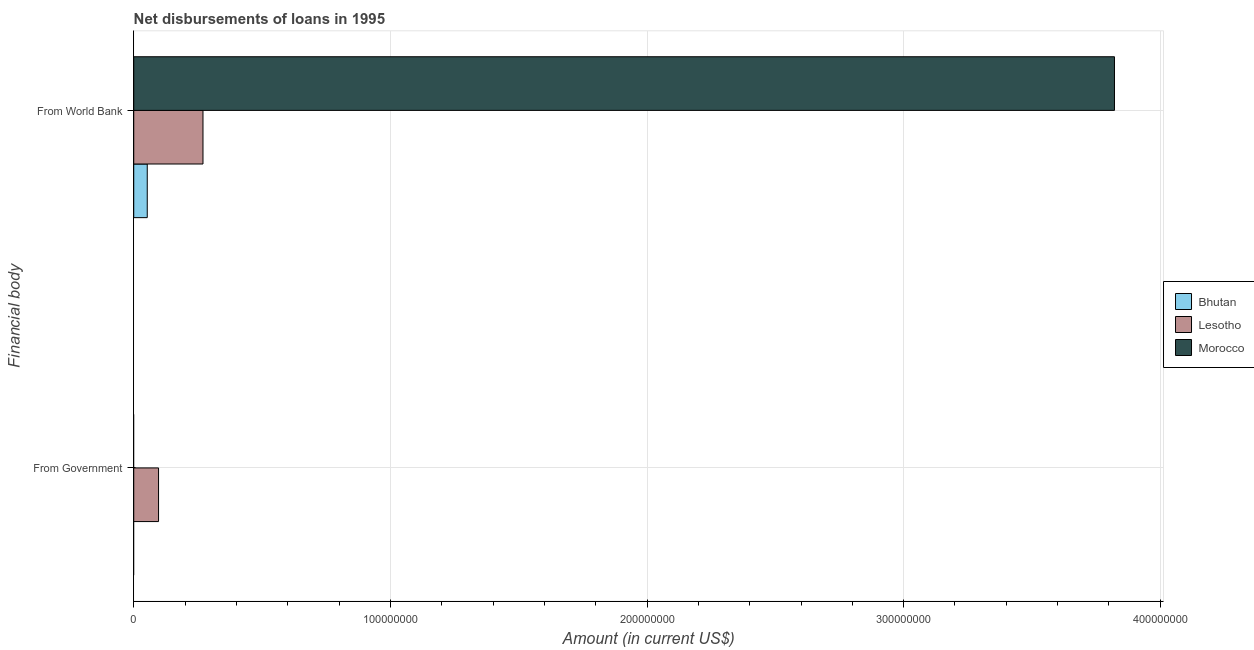How many different coloured bars are there?
Your answer should be compact. 3. How many bars are there on the 1st tick from the top?
Provide a succinct answer. 3. What is the label of the 1st group of bars from the top?
Your answer should be compact. From World Bank. What is the net disbursements of loan from government in Morocco?
Offer a very short reply. 0. Across all countries, what is the maximum net disbursements of loan from world bank?
Your answer should be very brief. 3.82e+08. Across all countries, what is the minimum net disbursements of loan from government?
Give a very brief answer. 0. In which country was the net disbursements of loan from government maximum?
Your response must be concise. Lesotho. What is the total net disbursements of loan from world bank in the graph?
Your response must be concise. 4.14e+08. What is the difference between the net disbursements of loan from world bank in Morocco and that in Lesotho?
Give a very brief answer. 3.55e+08. What is the difference between the net disbursements of loan from world bank in Lesotho and the net disbursements of loan from government in Bhutan?
Your answer should be compact. 2.70e+07. What is the average net disbursements of loan from world bank per country?
Provide a succinct answer. 1.38e+08. What is the difference between the net disbursements of loan from world bank and net disbursements of loan from government in Lesotho?
Keep it short and to the point. 1.73e+07. In how many countries, is the net disbursements of loan from government greater than 20000000 US$?
Your answer should be compact. 0. What is the ratio of the net disbursements of loan from world bank in Morocco to that in Lesotho?
Keep it short and to the point. 14.16. How many bars are there?
Your answer should be very brief. 4. Are all the bars in the graph horizontal?
Your answer should be very brief. Yes. What is the difference between two consecutive major ticks on the X-axis?
Keep it short and to the point. 1.00e+08. Are the values on the major ticks of X-axis written in scientific E-notation?
Offer a terse response. No. Does the graph contain grids?
Offer a terse response. Yes. Where does the legend appear in the graph?
Keep it short and to the point. Center right. What is the title of the graph?
Ensure brevity in your answer.  Net disbursements of loans in 1995. Does "South Sudan" appear as one of the legend labels in the graph?
Your answer should be compact. No. What is the label or title of the Y-axis?
Make the answer very short. Financial body. What is the Amount (in current US$) in Lesotho in From Government?
Your answer should be very brief. 9.67e+06. What is the Amount (in current US$) of Bhutan in From World Bank?
Your answer should be very brief. 5.26e+06. What is the Amount (in current US$) in Lesotho in From World Bank?
Offer a terse response. 2.70e+07. What is the Amount (in current US$) of Morocco in From World Bank?
Your response must be concise. 3.82e+08. Across all Financial body, what is the maximum Amount (in current US$) of Bhutan?
Provide a succinct answer. 5.26e+06. Across all Financial body, what is the maximum Amount (in current US$) in Lesotho?
Make the answer very short. 2.70e+07. Across all Financial body, what is the maximum Amount (in current US$) of Morocco?
Provide a short and direct response. 3.82e+08. Across all Financial body, what is the minimum Amount (in current US$) of Lesotho?
Ensure brevity in your answer.  9.67e+06. What is the total Amount (in current US$) in Bhutan in the graph?
Offer a terse response. 5.26e+06. What is the total Amount (in current US$) of Lesotho in the graph?
Provide a short and direct response. 3.66e+07. What is the total Amount (in current US$) in Morocco in the graph?
Make the answer very short. 3.82e+08. What is the difference between the Amount (in current US$) of Lesotho in From Government and that in From World Bank?
Offer a terse response. -1.73e+07. What is the difference between the Amount (in current US$) of Lesotho in From Government and the Amount (in current US$) of Morocco in From World Bank?
Your answer should be very brief. -3.72e+08. What is the average Amount (in current US$) of Bhutan per Financial body?
Offer a terse response. 2.63e+06. What is the average Amount (in current US$) in Lesotho per Financial body?
Provide a succinct answer. 1.83e+07. What is the average Amount (in current US$) of Morocco per Financial body?
Give a very brief answer. 1.91e+08. What is the difference between the Amount (in current US$) of Bhutan and Amount (in current US$) of Lesotho in From World Bank?
Ensure brevity in your answer.  -2.17e+07. What is the difference between the Amount (in current US$) in Bhutan and Amount (in current US$) in Morocco in From World Bank?
Provide a succinct answer. -3.77e+08. What is the difference between the Amount (in current US$) of Lesotho and Amount (in current US$) of Morocco in From World Bank?
Your response must be concise. -3.55e+08. What is the ratio of the Amount (in current US$) of Lesotho in From Government to that in From World Bank?
Keep it short and to the point. 0.36. What is the difference between the highest and the second highest Amount (in current US$) of Lesotho?
Make the answer very short. 1.73e+07. What is the difference between the highest and the lowest Amount (in current US$) in Bhutan?
Give a very brief answer. 5.26e+06. What is the difference between the highest and the lowest Amount (in current US$) of Lesotho?
Your response must be concise. 1.73e+07. What is the difference between the highest and the lowest Amount (in current US$) in Morocco?
Keep it short and to the point. 3.82e+08. 